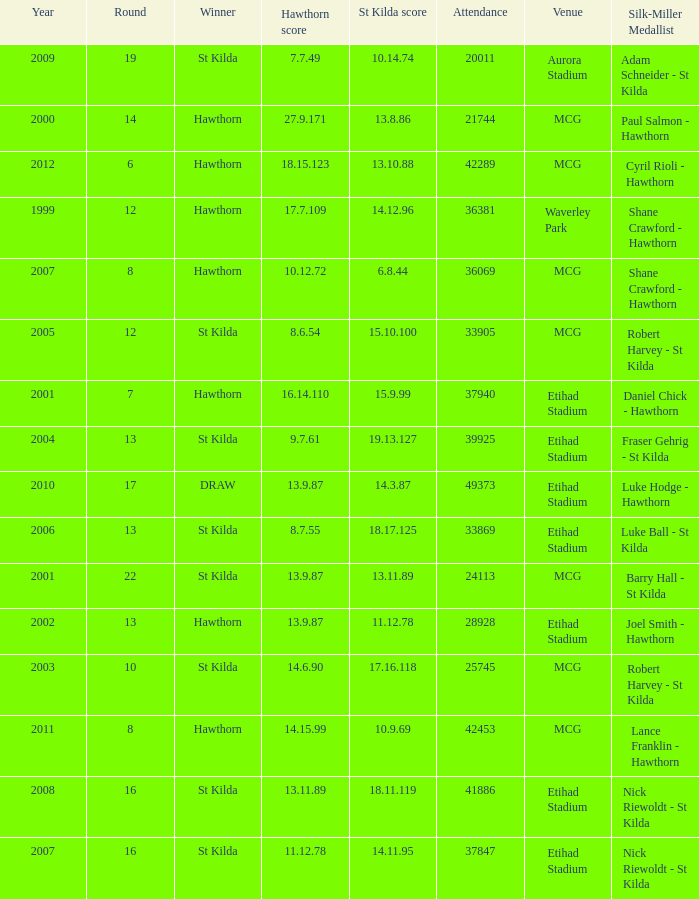How many winners have st kilda score at 14.11.95? 1.0. 